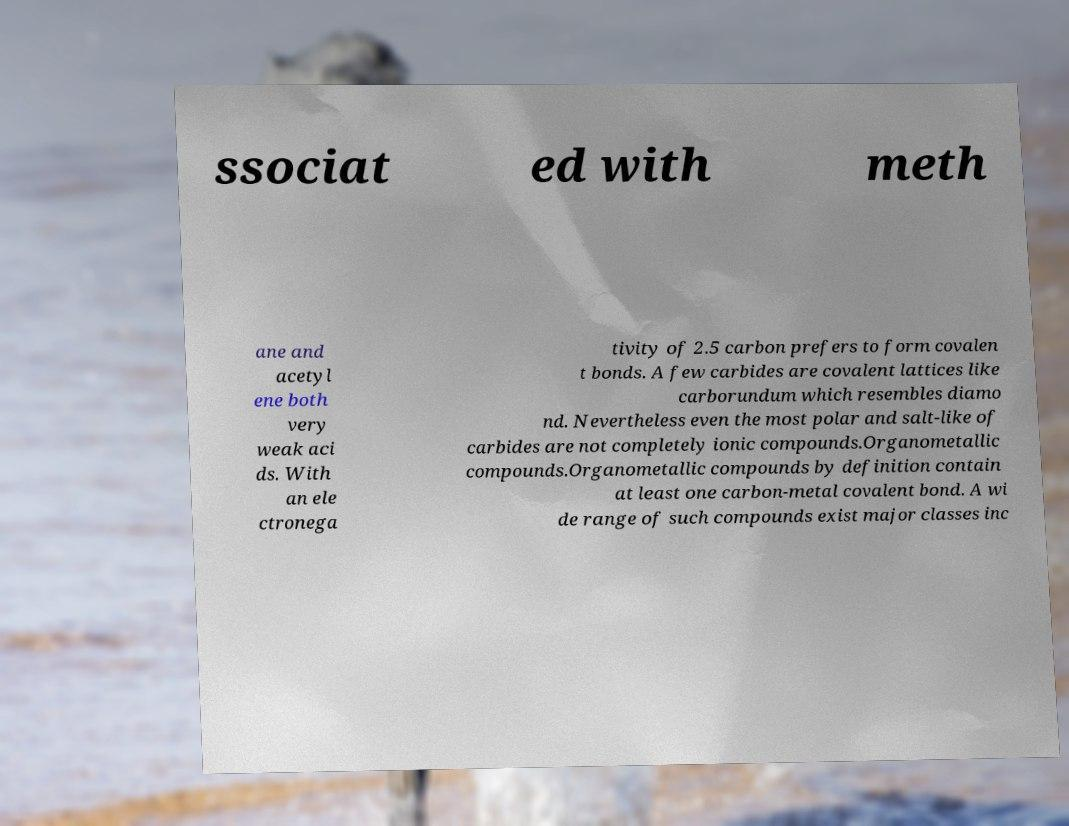Could you assist in decoding the text presented in this image and type it out clearly? ssociat ed with meth ane and acetyl ene both very weak aci ds. With an ele ctronega tivity of 2.5 carbon prefers to form covalen t bonds. A few carbides are covalent lattices like carborundum which resembles diamo nd. Nevertheless even the most polar and salt-like of carbides are not completely ionic compounds.Organometallic compounds.Organometallic compounds by definition contain at least one carbon-metal covalent bond. A wi de range of such compounds exist major classes inc 